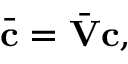Convert formula to latex. <formula><loc_0><loc_0><loc_500><loc_500>\bar { c } = \bar { V } c ,</formula> 